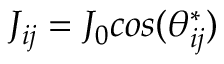Convert formula to latex. <formula><loc_0><loc_0><loc_500><loc_500>J _ { i j } = J _ { 0 } \cos ( \theta _ { i j } ^ { * } )</formula> 